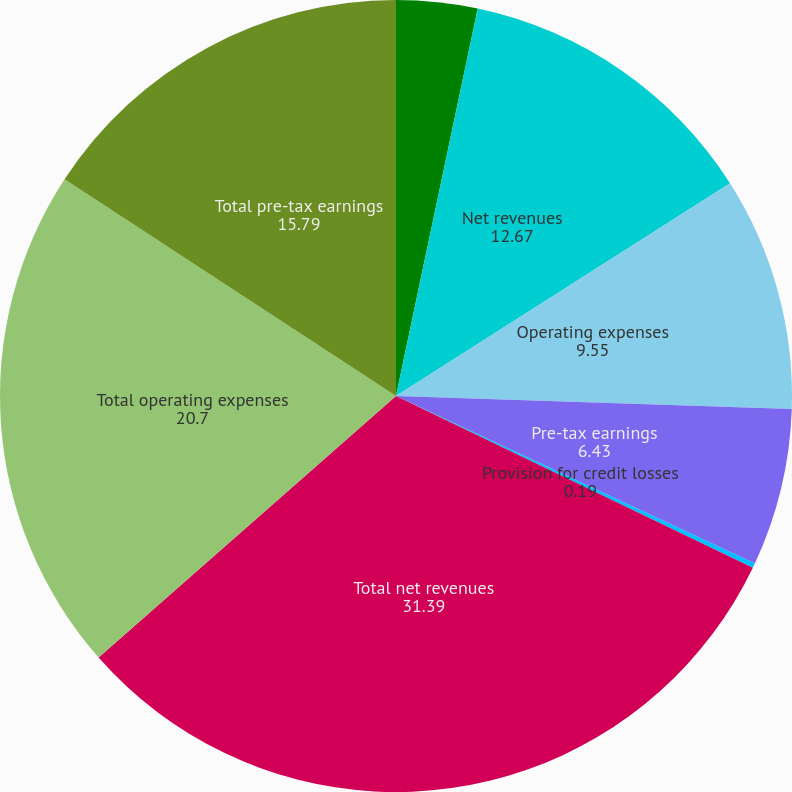Convert chart. <chart><loc_0><loc_0><loc_500><loc_500><pie_chart><fcel>in millions<fcel>Net revenues<fcel>Operating expenses<fcel>Pre-tax earnings<fcel>Provision for credit losses<fcel>Total net revenues<fcel>Total operating expenses<fcel>Total pre-tax earnings<nl><fcel>3.31%<fcel>12.67%<fcel>9.55%<fcel>6.43%<fcel>0.19%<fcel>31.39%<fcel>20.7%<fcel>15.79%<nl></chart> 